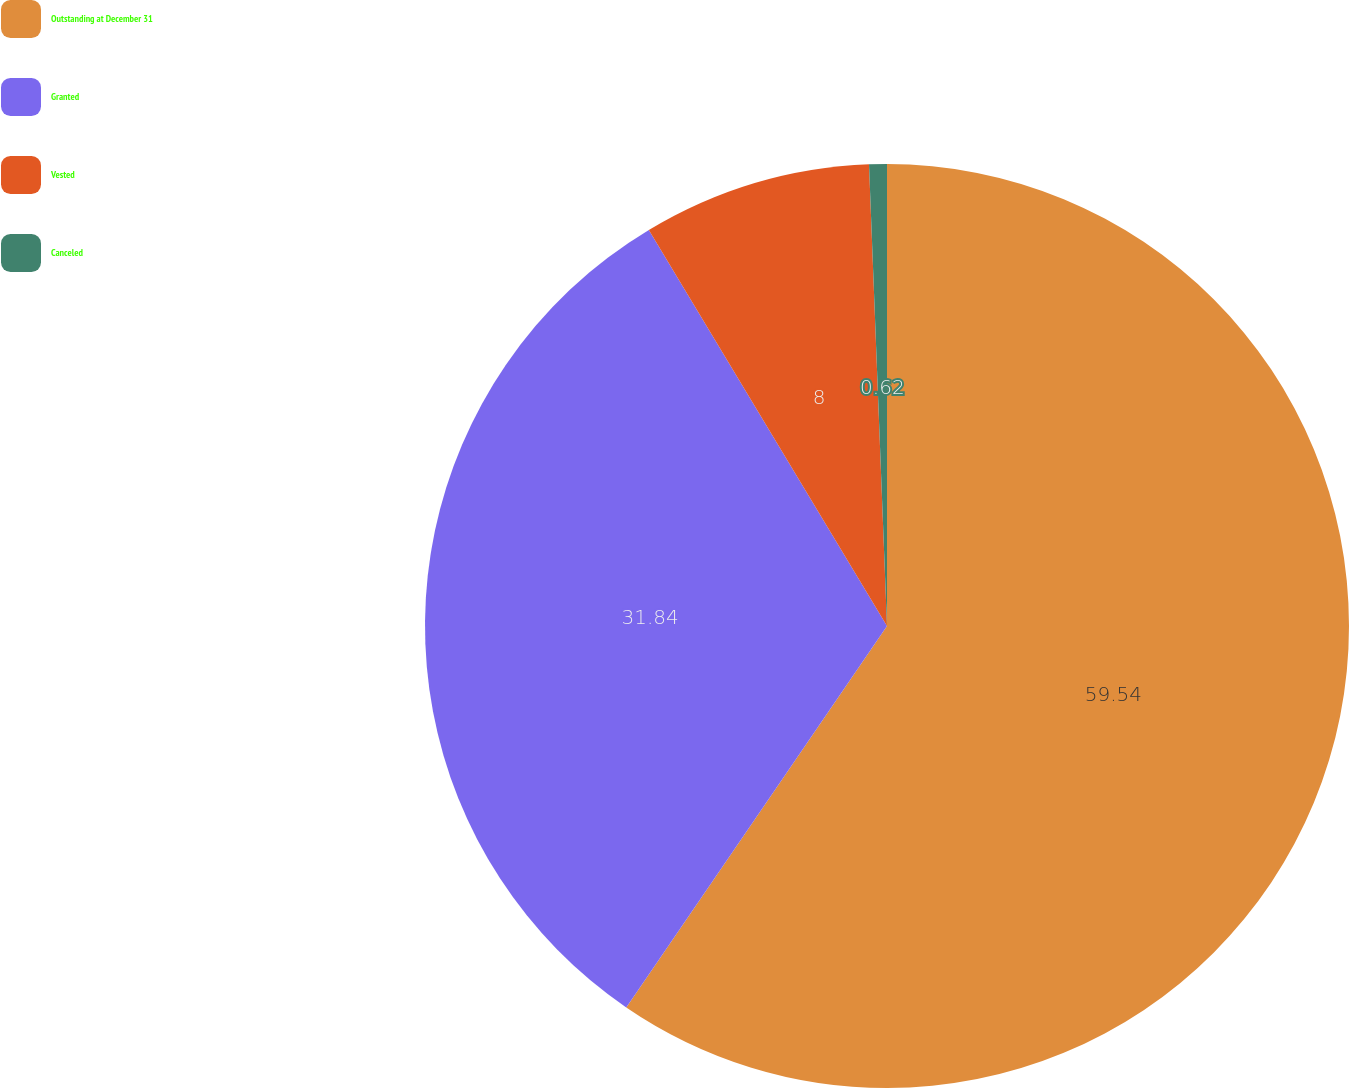Convert chart. <chart><loc_0><loc_0><loc_500><loc_500><pie_chart><fcel>Outstanding at December 31<fcel>Granted<fcel>Vested<fcel>Canceled<nl><fcel>59.55%<fcel>31.84%<fcel>8.0%<fcel>0.62%<nl></chart> 